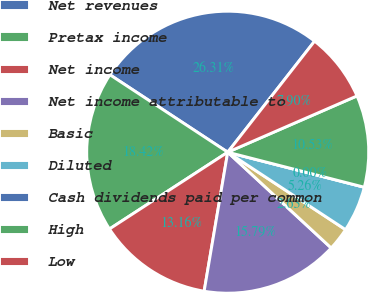Convert chart. <chart><loc_0><loc_0><loc_500><loc_500><pie_chart><fcel>Net revenues<fcel>Pretax income<fcel>Net income<fcel>Net income attributable to<fcel>Basic<fcel>Diluted<fcel>Cash dividends paid per common<fcel>High<fcel>Low<nl><fcel>26.31%<fcel>18.42%<fcel>13.16%<fcel>15.79%<fcel>2.63%<fcel>5.26%<fcel>0.0%<fcel>10.53%<fcel>7.9%<nl></chart> 